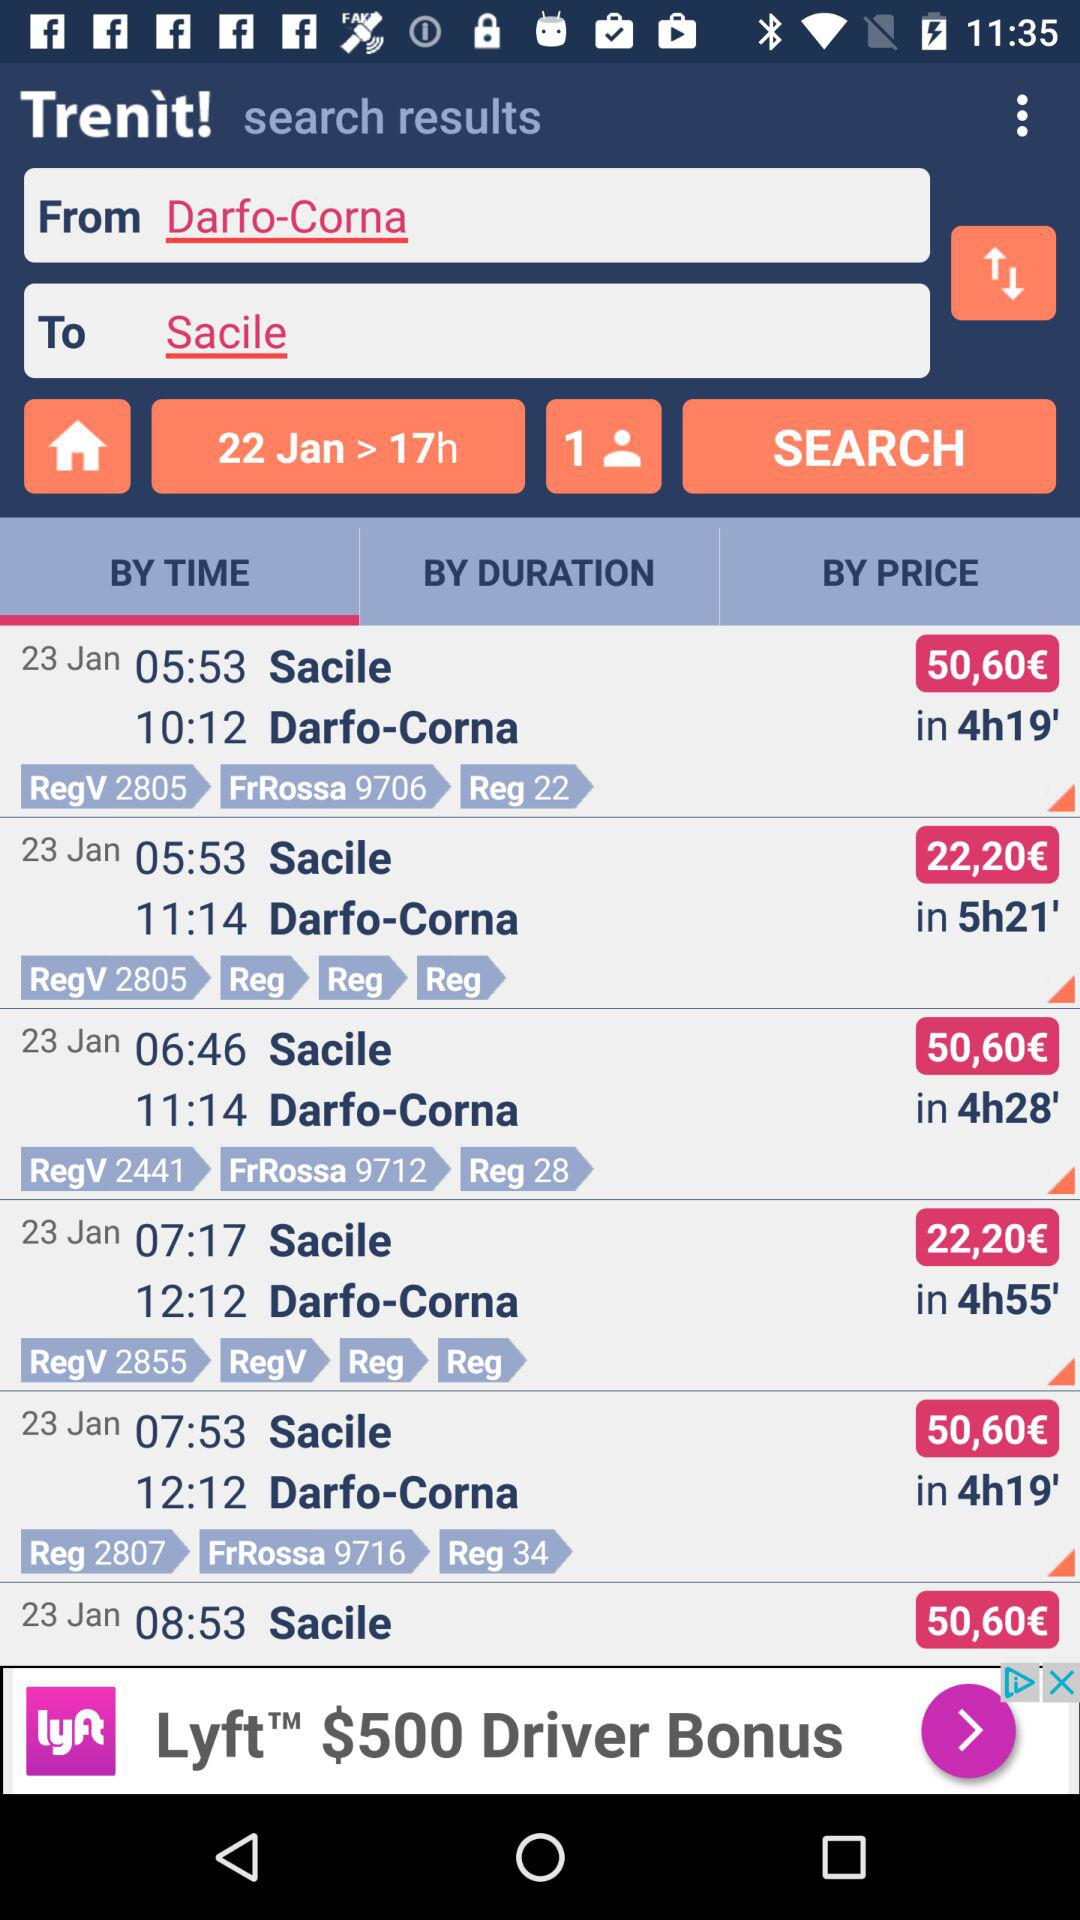What is the selected date? The selected date is 22 January. 